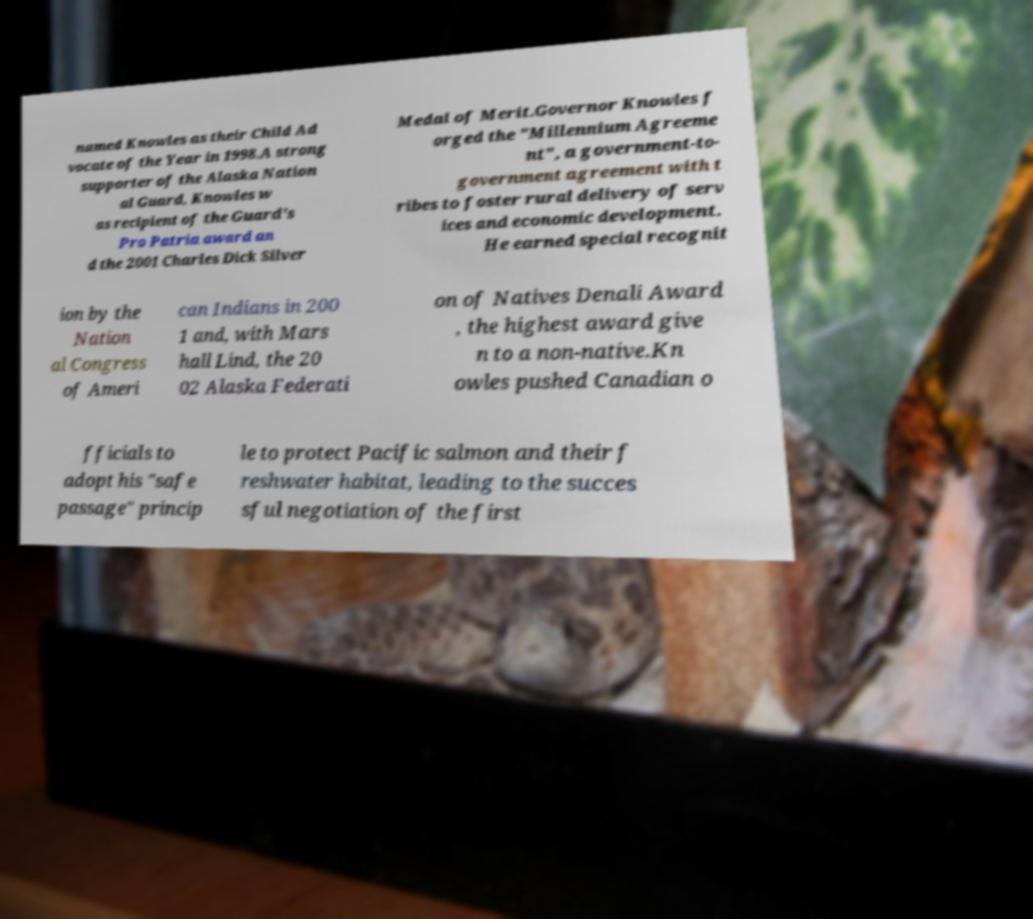Could you extract and type out the text from this image? named Knowles as their Child Ad vocate of the Year in 1998.A strong supporter of the Alaska Nation al Guard, Knowles w as recipient of the Guard's Pro Patria award an d the 2001 Charles Dick Silver Medal of Merit.Governor Knowles f orged the "Millennium Agreeme nt", a government-to- government agreement with t ribes to foster rural delivery of serv ices and economic development. He earned special recognit ion by the Nation al Congress of Ameri can Indians in 200 1 and, with Mars hall Lind, the 20 02 Alaska Federati on of Natives Denali Award , the highest award give n to a non-native.Kn owles pushed Canadian o fficials to adopt his "safe passage" princip le to protect Pacific salmon and their f reshwater habitat, leading to the succes sful negotiation of the first 